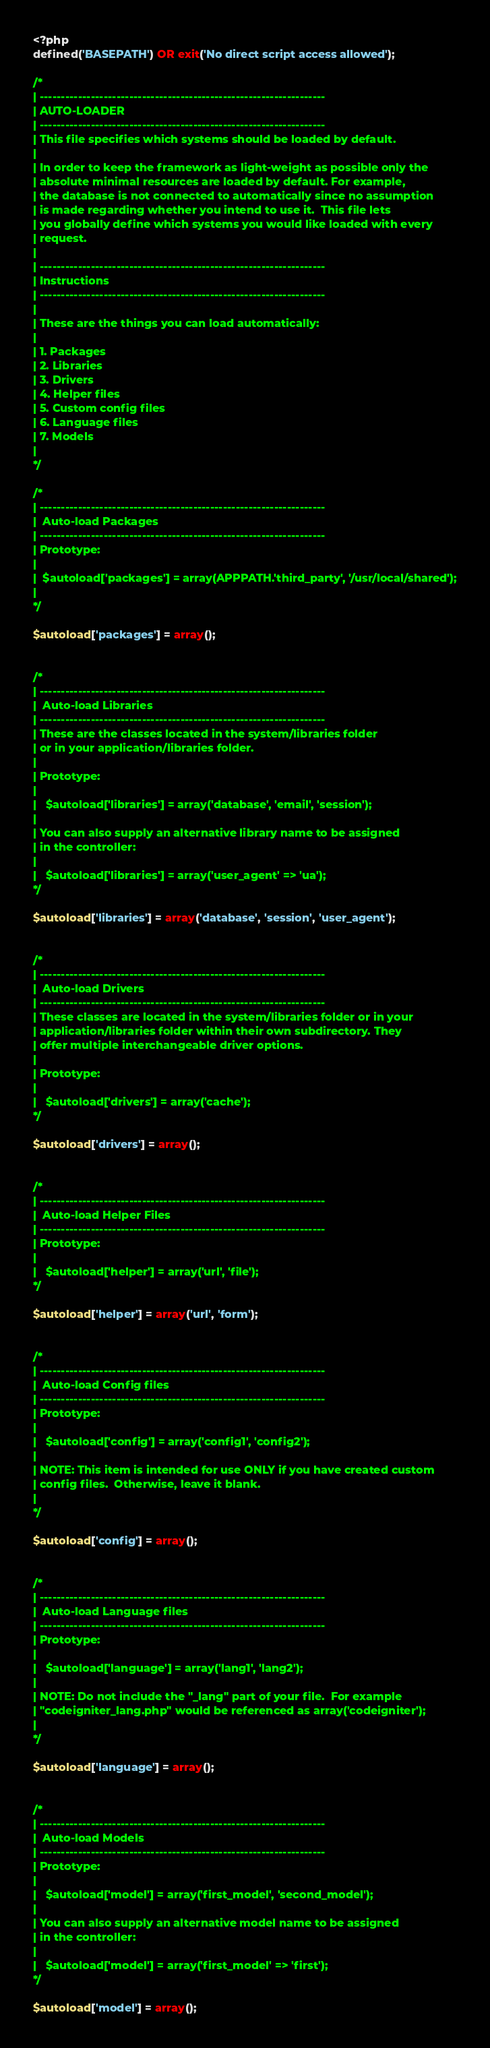Convert code to text. <code><loc_0><loc_0><loc_500><loc_500><_PHP_><?php
defined('BASEPATH') OR exit('No direct script access allowed');

/*
| -------------------------------------------------------------------
| AUTO-LOADER
| -------------------------------------------------------------------
| This file specifies which systems should be loaded by default.
|
| In order to keep the framework as light-weight as possible only the
| absolute minimal resources are loaded by default. For example,
| the database is not connected to automatically since no assumption
| is made regarding whether you intend to use it.  This file lets
| you globally define which systems you would like loaded with every
| request.
|
| -------------------------------------------------------------------
| Instructions
| -------------------------------------------------------------------
|
| These are the things you can load automatically:
|
| 1. Packages
| 2. Libraries
| 3. Drivers
| 4. Helper files
| 5. Custom config files
| 6. Language files
| 7. Models
|
*/

/*
| -------------------------------------------------------------------
|  Auto-load Packages
| -------------------------------------------------------------------
| Prototype:
|
|  $autoload['packages'] = array(APPPATH.'third_party', '/usr/local/shared');
|
*/

$autoload['packages'] = array();


/*
| -------------------------------------------------------------------
|  Auto-load Libraries
| -------------------------------------------------------------------
| These are the classes located in the system/libraries folder
| or in your application/libraries folder.
|
| Prototype:
|
|	$autoload['libraries'] = array('database', 'email', 'session');
|
| You can also supply an alternative library name to be assigned
| in the controller:
|
|	$autoload['libraries'] = array('user_agent' => 'ua');
*/

$autoload['libraries'] = array('database', 'session', 'user_agent');


/*
| -------------------------------------------------------------------
|  Auto-load Drivers
| -------------------------------------------------------------------
| These classes are located in the system/libraries folder or in your
| application/libraries folder within their own subdirectory. They
| offer multiple interchangeable driver options.
|
| Prototype:
|
|	$autoload['drivers'] = array('cache');
*/

$autoload['drivers'] = array();


/*
| -------------------------------------------------------------------
|  Auto-load Helper Files
| -------------------------------------------------------------------
| Prototype:
|
|	$autoload['helper'] = array('url', 'file');
*/

$autoload['helper'] = array('url', 'form');


/*
| -------------------------------------------------------------------
|  Auto-load Config files
| -------------------------------------------------------------------
| Prototype:
|
|	$autoload['config'] = array('config1', 'config2');
|
| NOTE: This item is intended for use ONLY if you have created custom
| config files.  Otherwise, leave it blank.
|
*/

$autoload['config'] = array();


/*
| -------------------------------------------------------------------
|  Auto-load Language files
| -------------------------------------------------------------------
| Prototype:
|
|	$autoload['language'] = array('lang1', 'lang2');
|
| NOTE: Do not include the "_lang" part of your file.  For example
| "codeigniter_lang.php" would be referenced as array('codeigniter');
|
*/

$autoload['language'] = array();


/*
| -------------------------------------------------------------------
|  Auto-load Models
| -------------------------------------------------------------------
| Prototype:
|
|	$autoload['model'] = array('first_model', 'second_model');
|
| You can also supply an alternative model name to be assigned
| in the controller:
|
|	$autoload['model'] = array('first_model' => 'first');
*/

$autoload['model'] = array();
</code> 